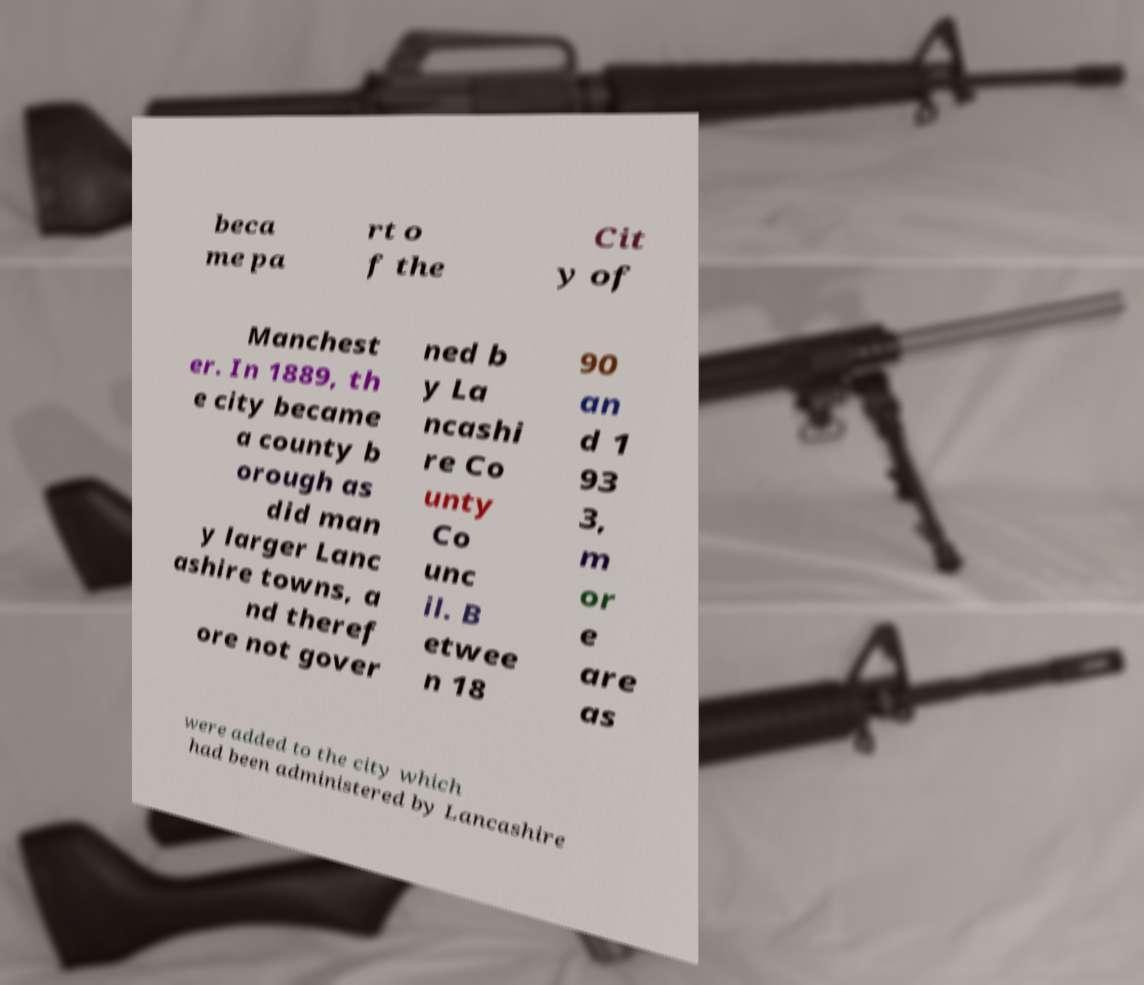There's text embedded in this image that I need extracted. Can you transcribe it verbatim? beca me pa rt o f the Cit y of Manchest er. In 1889, th e city became a county b orough as did man y larger Lanc ashire towns, a nd theref ore not gover ned b y La ncashi re Co unty Co unc il. B etwee n 18 90 an d 1 93 3, m or e are as were added to the city which had been administered by Lancashire 